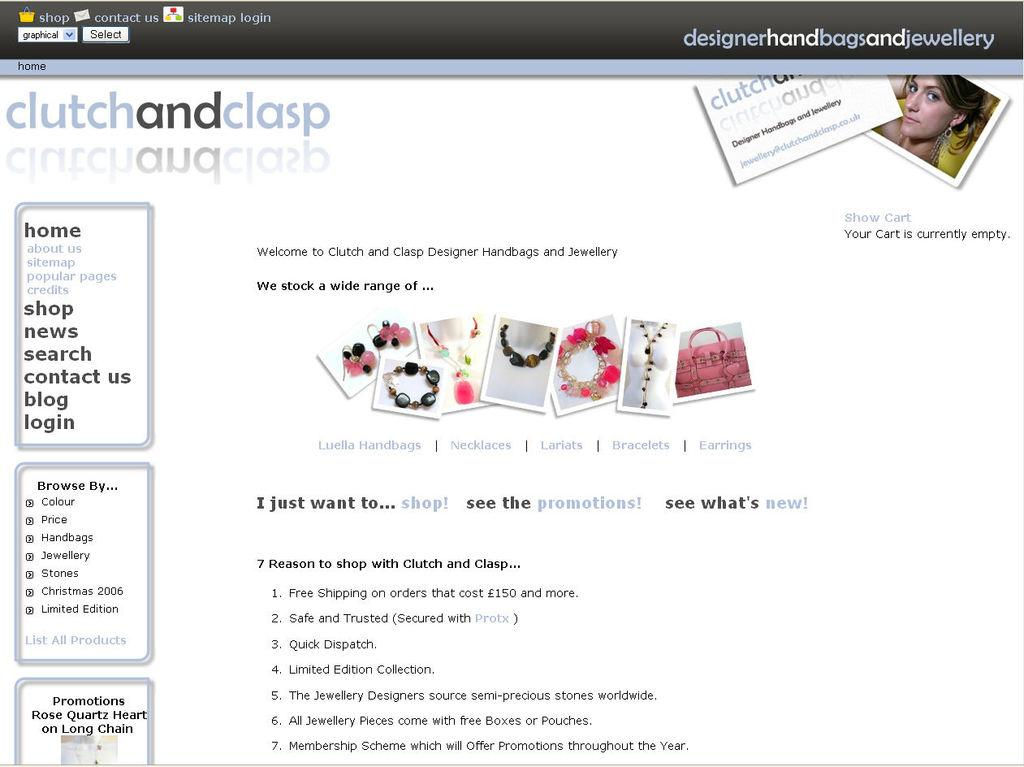What type of content is displayed in the image? The image contains a screenshot of a website. What kind of images can be seen on the website? There are pictures of ornaments and a picture of a woman on the website. What is the color of the text on the website? The text on the website is written in black color. What is the judge's temper like during the hearing in the image? There is no judge or hearing present in the image; it is a screenshot of a website with pictures of ornaments and a woman, along with black text. 